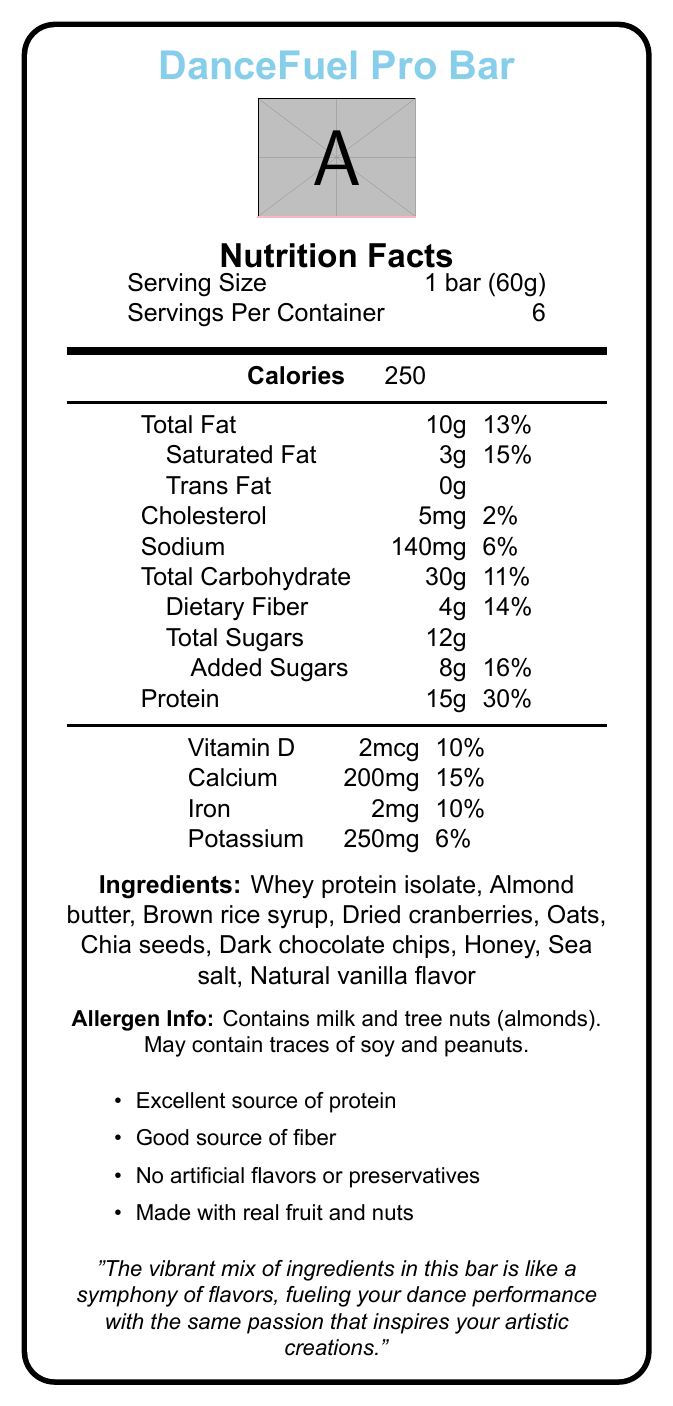What is the name of the product? The name of the product is clearly mentioned at the top of the document in large blue font.
Answer: DanceFuel Pro Bar What is the serving size of the DanceFuel Pro Bar? The serving size is specified in the "Nutrition Facts" section as "1 bar (60g)".
Answer: 1 bar (60g) How many servings are there per container? The number of servings per container is listed right under the serving size as "Servings Per Container: 6".
Answer: 6 How many calories does each serving provide? The calorie count per serving is highlighted prominently and listed as "Calories: 250".
Answer: 250 What is the total fat content per serving? The total fat content per serving is listed as "Total Fat: 10g" in the nutritional breakdown.
Answer: 10g How much protein does each bar provide? The protein content is listed further down in the nutritional information, noted as "Protein: 15g".
Answer: 15g How much dietary fiber is in each serving? The dietary fiber content is shown as "Dietary Fiber: 4g" within the carbohydrate section.
Answer: 4g Which of the following is NOT an ingredient in the DanceFuel Pro Bar? A. Whey protein isolate, B. Almond butter, C. Sugar, D. Sea salt The listed ingredients do not explicitly include "Sugar", only "Brown rice syrup" and "Honey" as sweeteners.
Answer: C. Sugar Which claim is made about the DanceFuel Pro Bar? A. Low in calories, B. Gluten-free, C. Excellent source of protein, D. Organic The claim is explicitly mentioned in the list of statements at the bottom: "Excellent source of protein".
Answer: C. Excellent source of protein Is this product a good source of fiber? It is explicitly stated in one of the claim statements: "Good source of fiber".
Answer: Yes Summarize the main idea of this document. The summary encapsulates the overall content of the document, which includes the nutritional breakdown, ingredients, allergen info, and product claims, all aimed at dancers.
Answer: The document provides detailed nutrition facts for the "DanceFuel Pro Bar", a protein-packed energy bar designed for dancers. It outlines serving size, nutritional content per serving, ingredients, allergen information, and various health claims about the product. How much Vitamin D is in each bar? The amount of Vitamin D is specified in the vitamins and minerals section as "Vitamin D: 2mcg".
Answer: 2mcg What is the percentage daily value of calcium provided by one bar? The percentage daily value for calcium is noted as "Calcium: 15%" in the nutritional content.
Answer: 15% Describe the allergen information for DanceFuel Pro Bar. This information is clearly provided at the bottom of the document in the allergen information section.
Answer: Contains milk and tree nuts (almonds). May contain traces of soy and peanuts. What artistic inspiration is noted for this product? This note is clearly mentioned at the end of the document as an artistic inspiration for the product.
Answer: The vibrant mix of ingredients in this bar is like a symphony of flavors, fueling your dance performance with the same passion that inspires your artistic creations. What are the total carbohydrate contents of each bar? The total carbohydrate content is listed as "Total Carbohydrate: 30g" in the nutrition facts section.
Answer: 30g What are the exact amounts of saturated fat and cholesterol per serving? These values are listed in the nutritional breakdown as "Saturated Fat: 3g" and "Cholesterol: 5mg" respectively.
Answer: Saturated Fat: 3g, Cholesterol: 5mg How much added sugar is in each bar, and what percentage of the daily value does it represent? Added sugars are listed as "8g" and the daily value percentage is indicated as "16%" in the carbohydrate section of the nutritional facts.
Answer: 8g, 16% What type of natural flavor is included in the ingredients? The ingredient list specifies "Natural vanilla flavor" near the end.
Answer: Natural vanilla flavor What image is included in the document? The information about the image cannot be determined from the text-based nutritional label provided.
Answer: Cannot be determined 